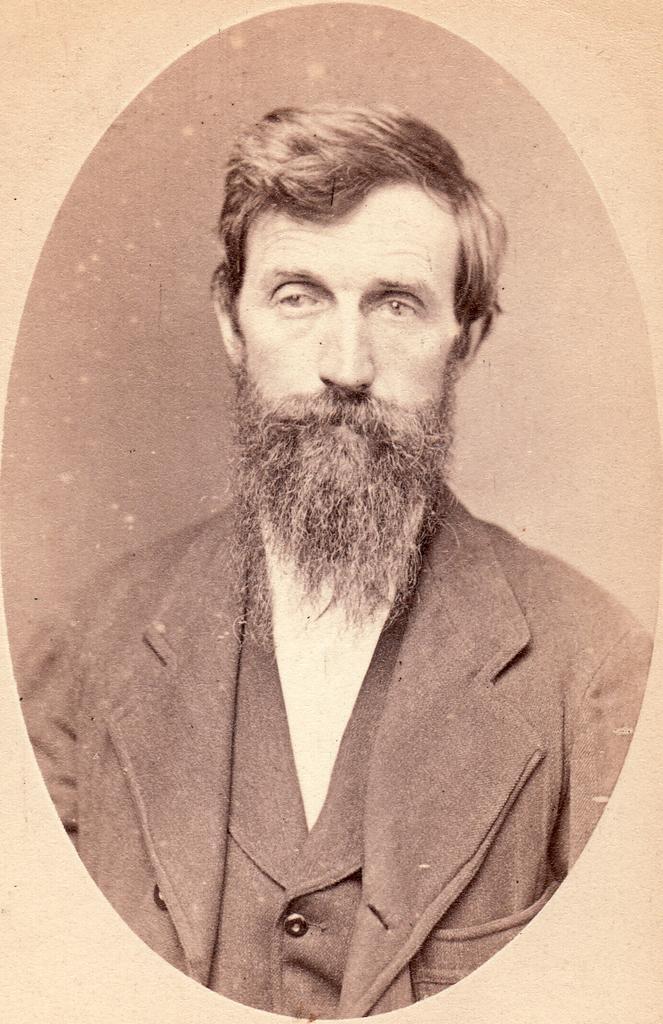Can you describe this image briefly? In this age we can see a photo frame of a man. 